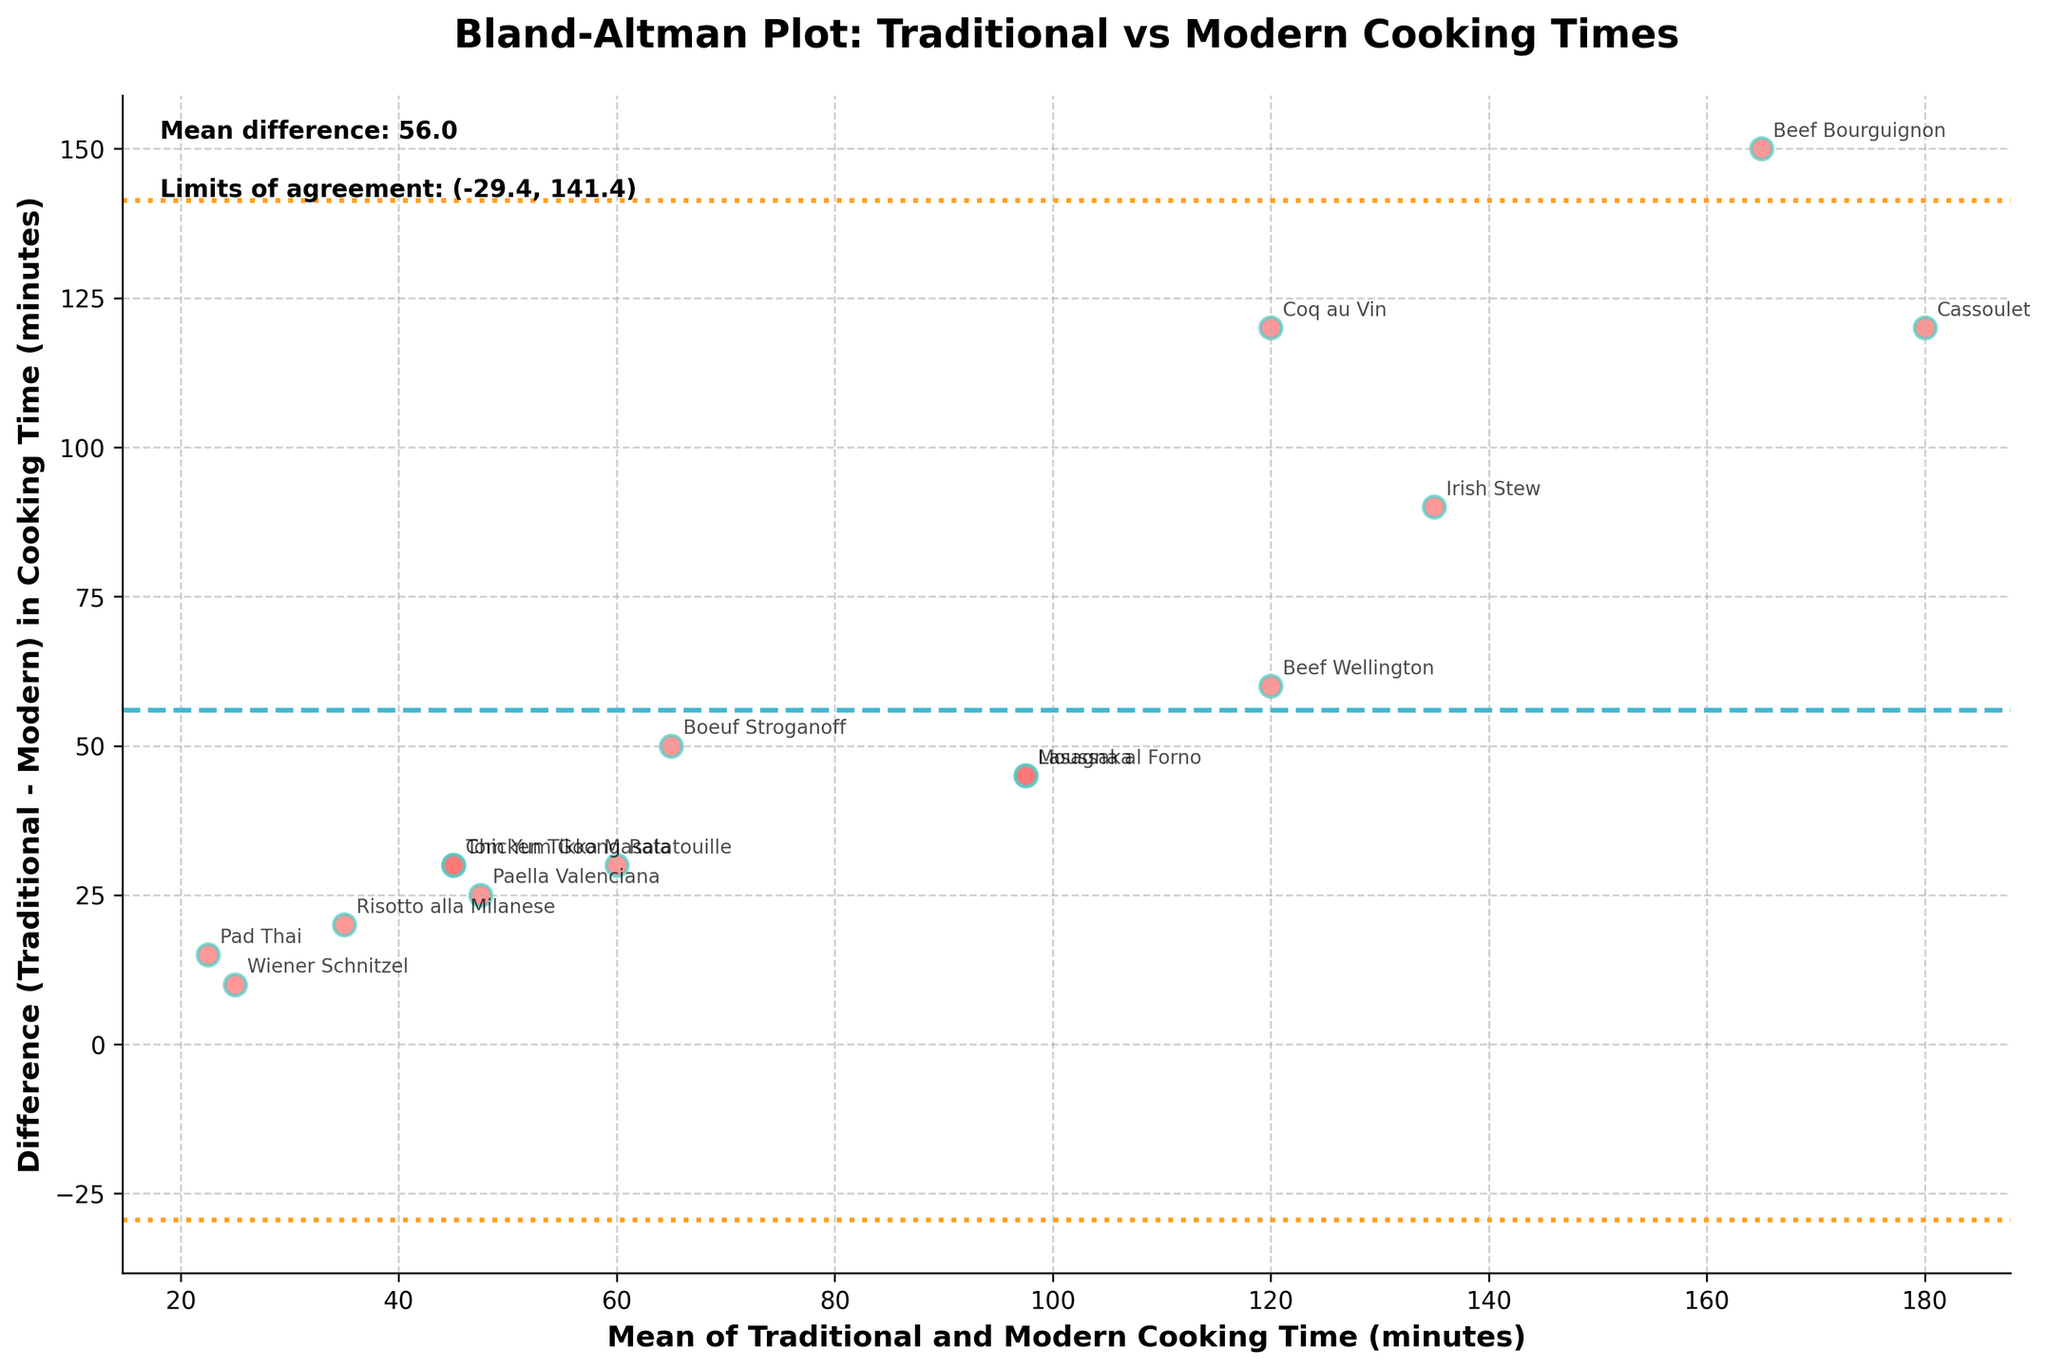What's the title of the plot? The plot's title is displayed at the top in bold. It helps provide context for what is being visualized.
Answer: Bland-Altman Plot: Traditional vs Modern Cooking Times How many recipes are compared in the figure? The recipes are represented by the data points on the plot, and there are labeled annotations for each recipe. Counting these can give the total number of recipes compared.
Answer: 15 What is the color of the data points? Observe the color used for the scatter points in the plot. They are visually distinct and labeled with specific recipes.
Answer: Red with green edges What is the mean difference between traditional and modern cooking times? The mean difference is explicitly stated in the text on the figure, usually near the top. It indicates the average offset in cooking times between the two methods.
Answer: 64.7 What do the dashed lines represent on the plot? The dashed horizontal lines indicate the mean difference between the traditional and modern cooking times, as shown in the plot legend and text.
Answer: Mean difference What is the range for the limits of agreement? The plot text indicates these values, representing the range within which most differences between traditional and modern cooking times fall. They are the dotted lines drawn above and below the mean difference line.
Answer: 25.5 to 103.9 Which recipe has the largest difference in cooking times? Identify the largest gap between a data point and the x-axis, which corresponds to the traditional time minus the modern time.
Answer: Cassoulet Which recipe has the smallest difference in cooking times? Look for the data point closest to the x-axis, showing the smallest difference between the traditional and modern cooking times.
Answer: Wiener Schnitzel What is the general trend seen in the differences as the mean cooking time increases? Observe how the points are distributed as the mean cooking time on the x-axis increases, providing insight into any patterns or trends.
Answer: Differences increase 